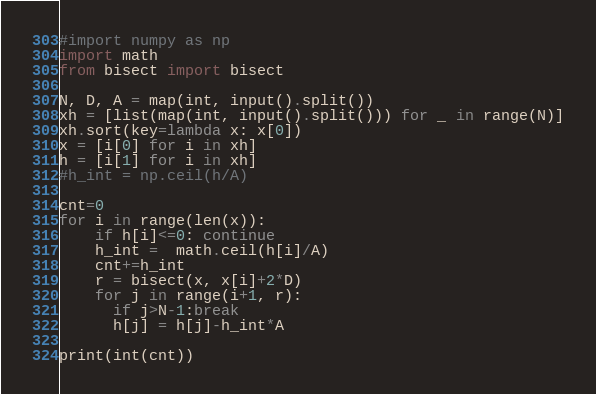Convert code to text. <code><loc_0><loc_0><loc_500><loc_500><_Python_>#import numpy as np
import math
from bisect import bisect

N, D, A = map(int, input().split())
xh = [list(map(int, input().split())) for _ in range(N)]
xh.sort(key=lambda x: x[0])
x = [i[0] for i in xh]
h = [i[1] for i in xh]
#h_int = np.ceil(h/A)

cnt=0
for i in range(len(x)):
    if h[i]<=0: continue
    h_int =  math.ceil(h[i]/A)
    cnt+=h_int
    r = bisect(x, x[i]+2*D)
    for j in range(i+1, r):
      if j>N-1:break
      h[j] = h[j]-h_int*A

print(int(cnt))</code> 